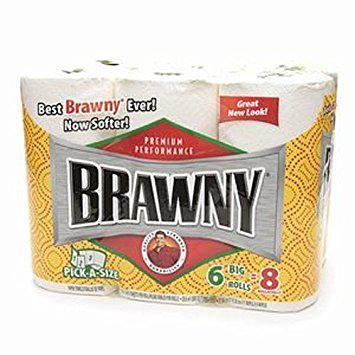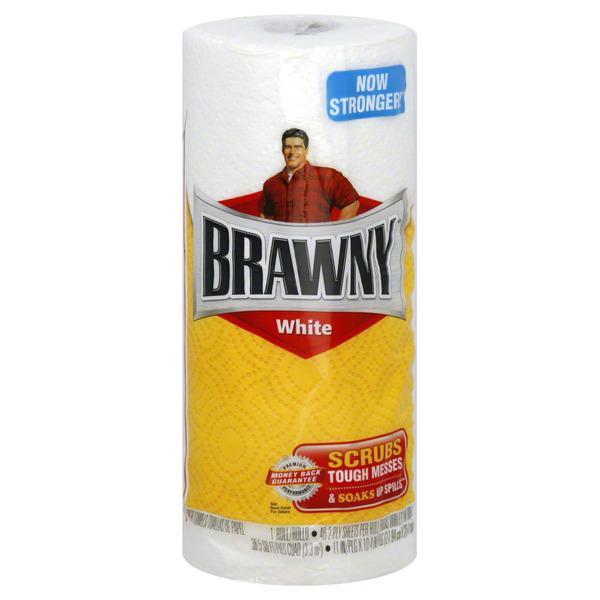The first image is the image on the left, the second image is the image on the right. Evaluate the accuracy of this statement regarding the images: "The left image contains at least six rolls of paper towels.". Is it true? Answer yes or no. Yes. The first image is the image on the left, the second image is the image on the right. Assess this claim about the two images: "The paper towel packaging on the left depicts a man in a red flannel shirt, but the paper towel packaging on the right does not.". Correct or not? Answer yes or no. No. 